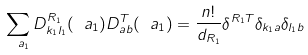Convert formula to latex. <formula><loc_0><loc_0><loc_500><loc_500>\sum _ { \ a _ { 1 } } D ^ { R _ { 1 } } _ { k _ { 1 } l _ { 1 } } ( \ a _ { 1 } ) D ^ { T } _ { a b } ( \ a _ { 1 } ) = \frac { n ! } { d _ { R _ { 1 } } } \delta ^ { R _ { 1 } T } \delta _ { k _ { 1 } a } \delta _ { l _ { 1 } b }</formula> 